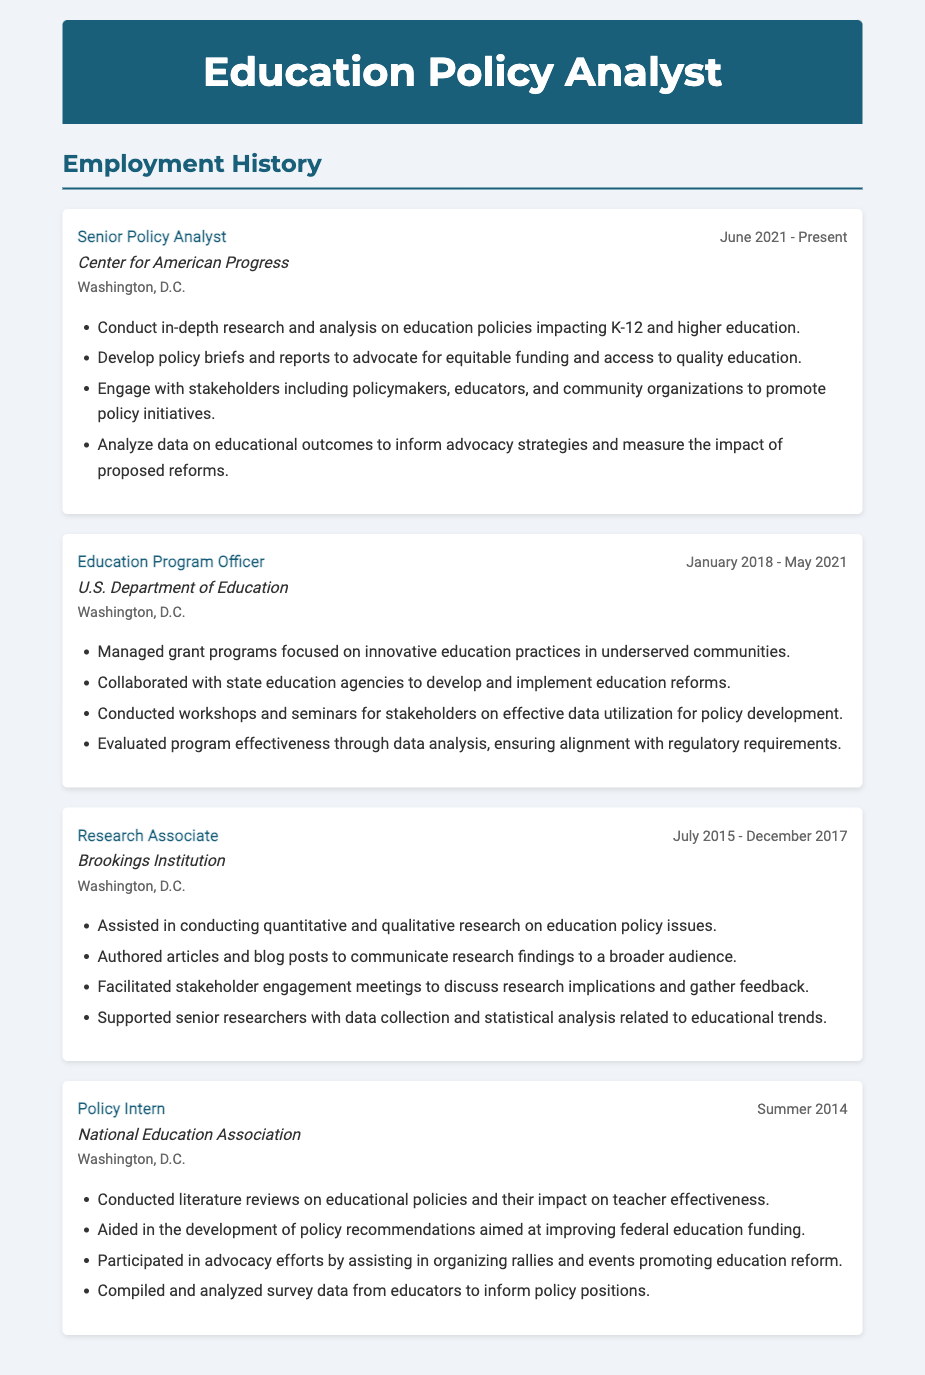What is the current job title of the analyst? The current job title is listed in the first position of the employment history as "Senior Policy Analyst."
Answer: Senior Policy Analyst When did the analyst start working at the Center for American Progress? The start date is found under the job dates for the "Senior Policy Analyst" position.
Answer: June 2021 Which organization did the analyst work for before joining the Center for American Progress? The previous organization is found in the employment history, listed before the current job.
Answer: U.S. Department of Education What type of data did the analyst compile and analyze while working as a Policy Intern? The specific type of data is mentioned in the job responsibilities under the "Policy Intern" position.
Answer: survey data Name one key responsibility of the Education Program Officer. The responsibilities of the "Education Program Officer" are listed in bullet points, one of which describes managing grant programs.
Answer: Managed grant programs How long did the analyst work at the Brookings Institution? The employment period for the "Research Associate" job is stated in the job dates section.
Answer: Two years and five months What is a primary role of the analyst at the Center for American Progress? The responsibilities include conducting research and developing policy briefs, which represents a primary role.
Answer: Conduct in-depth research What city are all the listed organizations located in? The city is mentioned underneath each job, indicating the location of all positions held.
Answer: Washington, D.C Which organization did the analyst intern for in the summer of 2014? The organization is specified under the position titled "Policy Intern."
Answer: National Education Association 